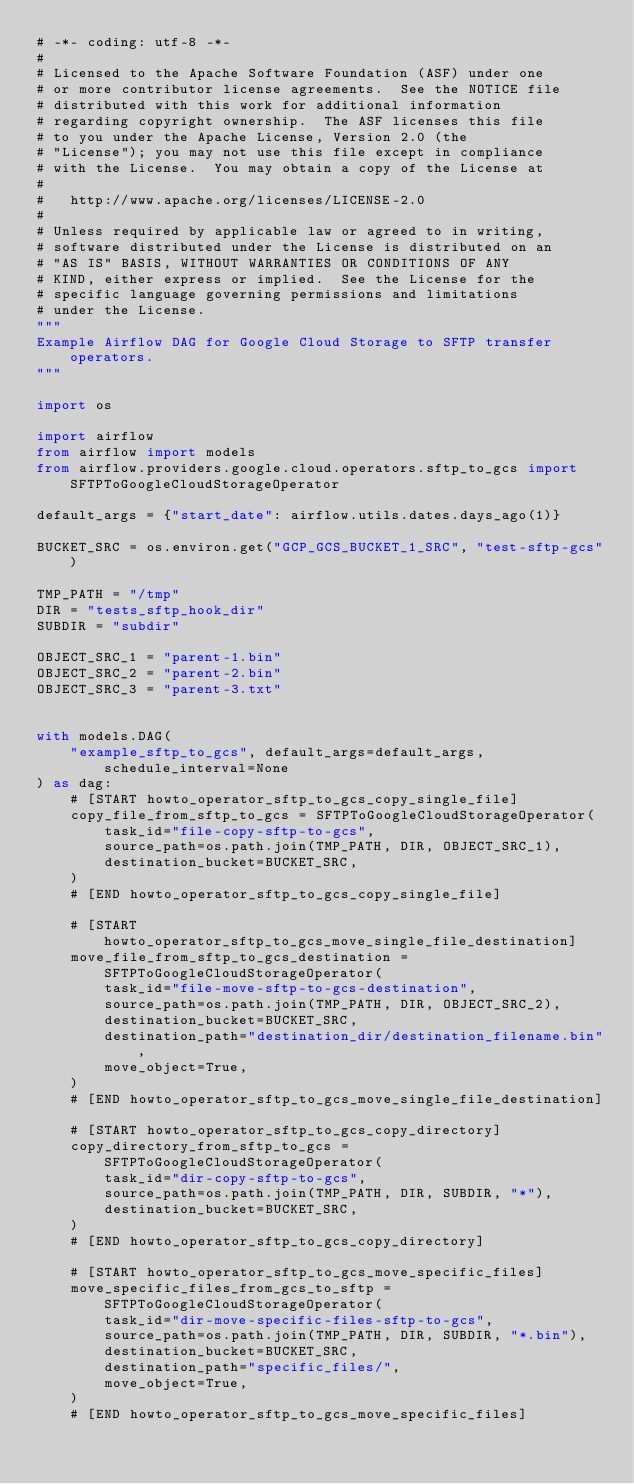Convert code to text. <code><loc_0><loc_0><loc_500><loc_500><_Python_># -*- coding: utf-8 -*-
#
# Licensed to the Apache Software Foundation (ASF) under one
# or more contributor license agreements.  See the NOTICE file
# distributed with this work for additional information
# regarding copyright ownership.  The ASF licenses this file
# to you under the Apache License, Version 2.0 (the
# "License"); you may not use this file except in compliance
# with the License.  You may obtain a copy of the License at
#
#   http://www.apache.org/licenses/LICENSE-2.0
#
# Unless required by applicable law or agreed to in writing,
# software distributed under the License is distributed on an
# "AS IS" BASIS, WITHOUT WARRANTIES OR CONDITIONS OF ANY
# KIND, either express or implied.  See the License for the
# specific language governing permissions and limitations
# under the License.
"""
Example Airflow DAG for Google Cloud Storage to SFTP transfer operators.
"""

import os

import airflow
from airflow import models
from airflow.providers.google.cloud.operators.sftp_to_gcs import SFTPToGoogleCloudStorageOperator

default_args = {"start_date": airflow.utils.dates.days_ago(1)}

BUCKET_SRC = os.environ.get("GCP_GCS_BUCKET_1_SRC", "test-sftp-gcs")

TMP_PATH = "/tmp"
DIR = "tests_sftp_hook_dir"
SUBDIR = "subdir"

OBJECT_SRC_1 = "parent-1.bin"
OBJECT_SRC_2 = "parent-2.bin"
OBJECT_SRC_3 = "parent-3.txt"


with models.DAG(
    "example_sftp_to_gcs", default_args=default_args, schedule_interval=None
) as dag:
    # [START howto_operator_sftp_to_gcs_copy_single_file]
    copy_file_from_sftp_to_gcs = SFTPToGoogleCloudStorageOperator(
        task_id="file-copy-sftp-to-gcs",
        source_path=os.path.join(TMP_PATH, DIR, OBJECT_SRC_1),
        destination_bucket=BUCKET_SRC,
    )
    # [END howto_operator_sftp_to_gcs_copy_single_file]

    # [START howto_operator_sftp_to_gcs_move_single_file_destination]
    move_file_from_sftp_to_gcs_destination = SFTPToGoogleCloudStorageOperator(
        task_id="file-move-sftp-to-gcs-destination",
        source_path=os.path.join(TMP_PATH, DIR, OBJECT_SRC_2),
        destination_bucket=BUCKET_SRC,
        destination_path="destination_dir/destination_filename.bin",
        move_object=True,
    )
    # [END howto_operator_sftp_to_gcs_move_single_file_destination]

    # [START howto_operator_sftp_to_gcs_copy_directory]
    copy_directory_from_sftp_to_gcs = SFTPToGoogleCloudStorageOperator(
        task_id="dir-copy-sftp-to-gcs",
        source_path=os.path.join(TMP_PATH, DIR, SUBDIR, "*"),
        destination_bucket=BUCKET_SRC,
    )
    # [END howto_operator_sftp_to_gcs_copy_directory]

    # [START howto_operator_sftp_to_gcs_move_specific_files]
    move_specific_files_from_gcs_to_sftp = SFTPToGoogleCloudStorageOperator(
        task_id="dir-move-specific-files-sftp-to-gcs",
        source_path=os.path.join(TMP_PATH, DIR, SUBDIR, "*.bin"),
        destination_bucket=BUCKET_SRC,
        destination_path="specific_files/",
        move_object=True,
    )
    # [END howto_operator_sftp_to_gcs_move_specific_files]
</code> 